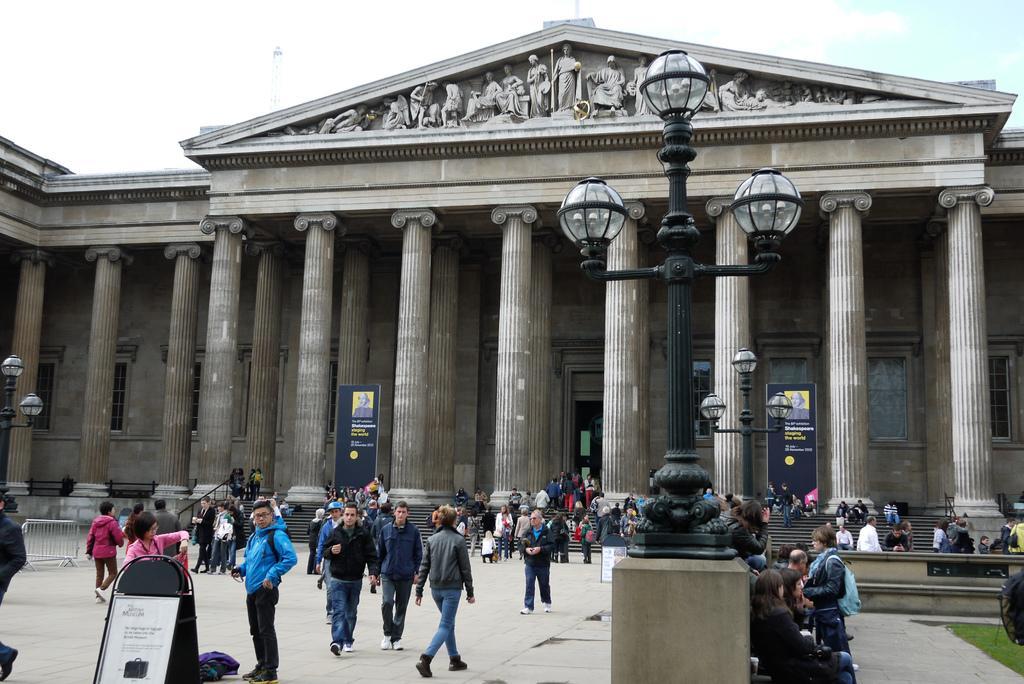Please provide a concise description of this image. This image is taken outdoors. At the bottom of the image there is a floor and a board with text on it. In the middle of the image there are a few poles with lights and a few people are walking on the floor and a few are standing. On the right side of the image a few people are sitting on the bench. In this image there are many people. In the background there is a building with walls, windows, pillars, stairs, and railing, a door and carvings. At the top of the image there is a sky with clouds. 